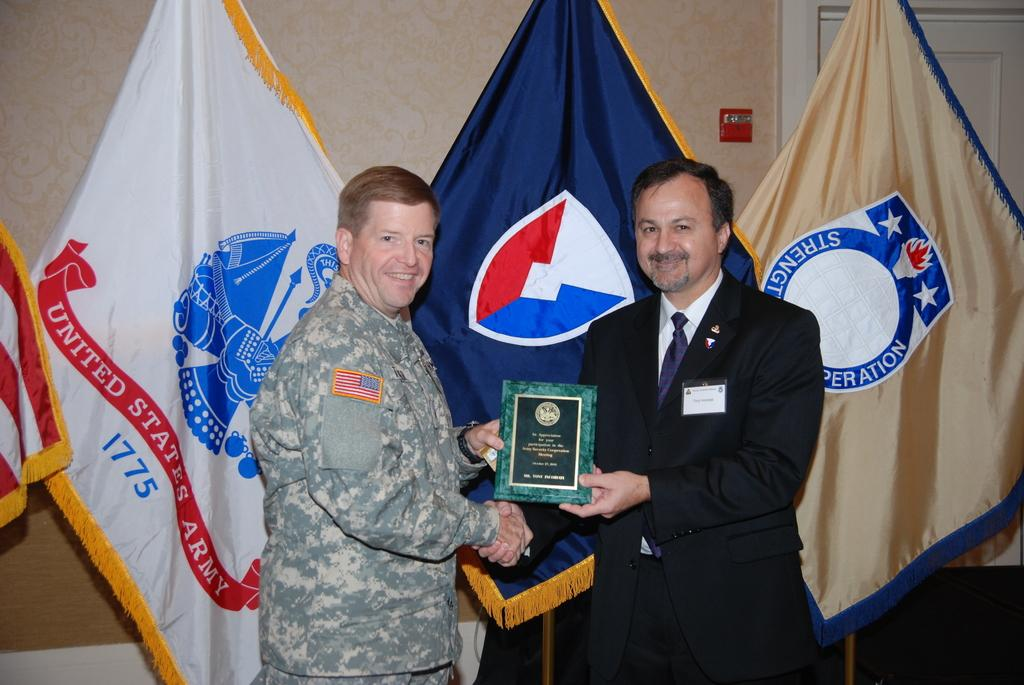<image>
Give a short and clear explanation of the subsequent image. A United States Army officer is presented with an award at a ceremony. 